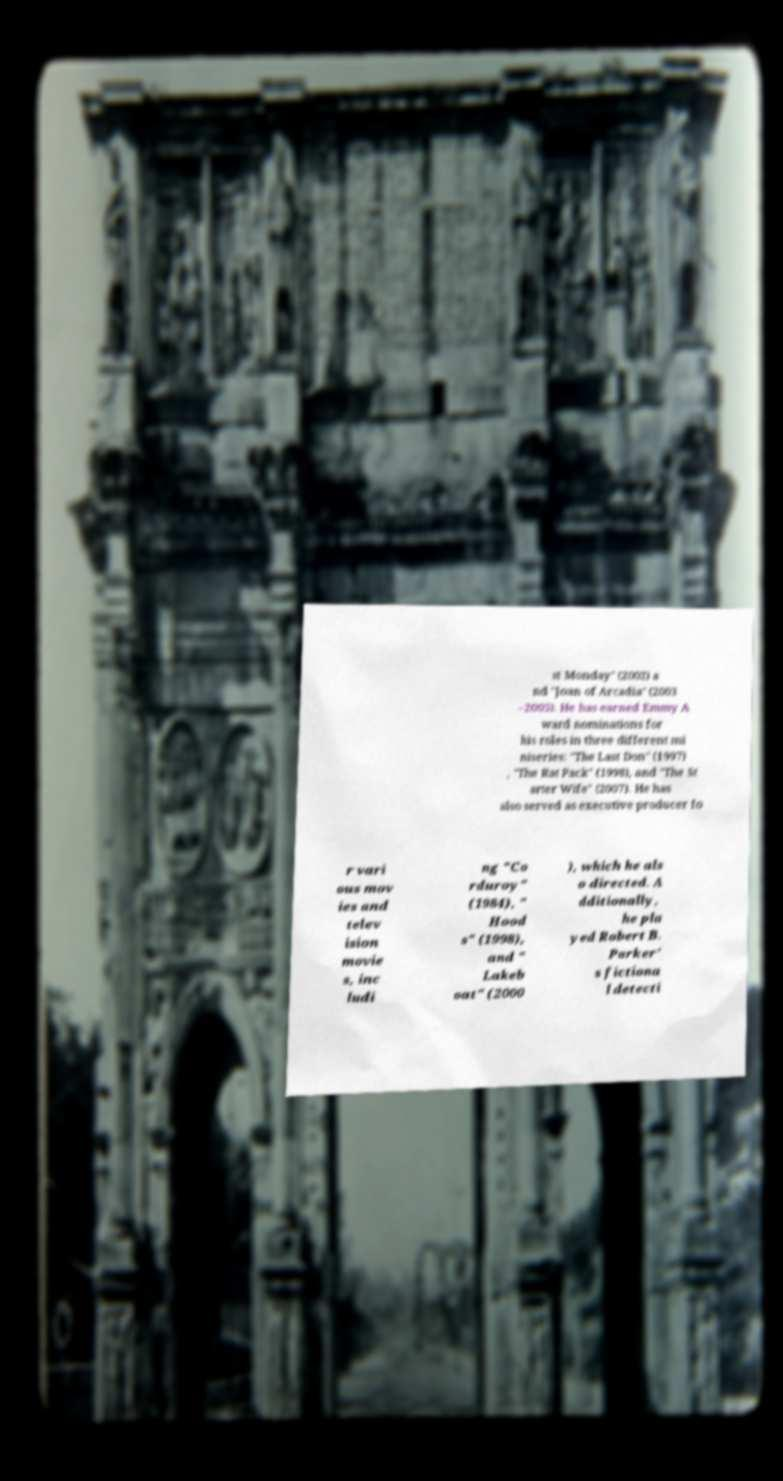Could you extract and type out the text from this image? st Monday" (2002) a nd "Joan of Arcadia" (2003 –2005). He has earned Emmy A ward nominations for his roles in three different mi niseries: "The Last Don" (1997) , "The Rat Pack" (1998), and "The St arter Wife" (2007). He has also served as executive producer fo r vari ous mov ies and telev ision movie s, inc ludi ng "Co rduroy" (1984), " Hood s" (1998), and " Lakeb oat" (2000 ), which he als o directed. A dditionally, he pla yed Robert B. Parker' s fictiona l detecti 